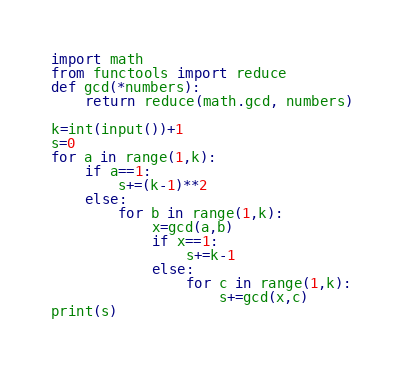Convert code to text. <code><loc_0><loc_0><loc_500><loc_500><_Python_>import math
from functools import reduce
def gcd(*numbers):
    return reduce(math.gcd, numbers)

k=int(input())+1
s=0
for a in range(1,k):
    if a==1:
        s+=(k-1)**2
    else:
        for b in range(1,k):
            x=gcd(a,b)
            if x==1:
                s+=k-1
            else:
                for c in range(1,k):
                    s+=gcd(x,c)
print(s)</code> 